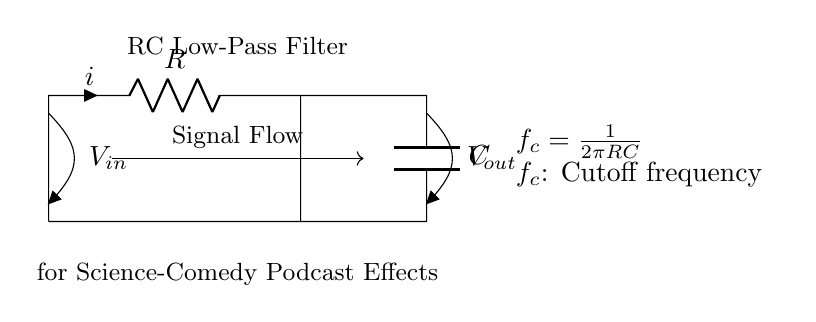What is the component labeled R? The component labeled R represents a resistor in the circuit, which is designed to impede the flow of electric current.
Answer: Resistor What is the component labeled C? The component labeled C represents a capacitor in the circuit, which stores and releases electrical energy.
Answer: Capacitor What is the voltage at the input labeled V_in? The voltage at the input labeled V_in is applied across the resistor and the capacitor; however, it is not specified in the circuit diagram.
Answer: Not specified What does the formula f_c = 1/(2πRC) represent? The formula indicates the cutoff frequency for the RC low-pass filter, which defines the frequency at which the output signal begins to drop off and is influenced by the values of R and C.
Answer: Cutoff frequency How does increasing the resistor value affect the cutoff frequency? Increasing the resistor value R in the formula f_c = 1/(2πRC) will decrease the cutoff frequency f_c, meaning the filter will allow lower frequencies to pass while blocking higher ones more effectively.
Answer: Decreases cutoff frequency What type of signals does this filter allow through? The RC low-pass filter allows low-frequency signals to pass through while attenuating high-frequency signals.
Answer: Low-frequency signals What is the effect of this circuit in audio applications? In audio applications, the RC low-pass filter can smooth out high-frequency noises or signals, creating a subtler and more mellow sound, suitable for comedic audio effects.
Answer: Smooths high frequencies 